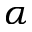<formula> <loc_0><loc_0><loc_500><loc_500>\alpha</formula> 